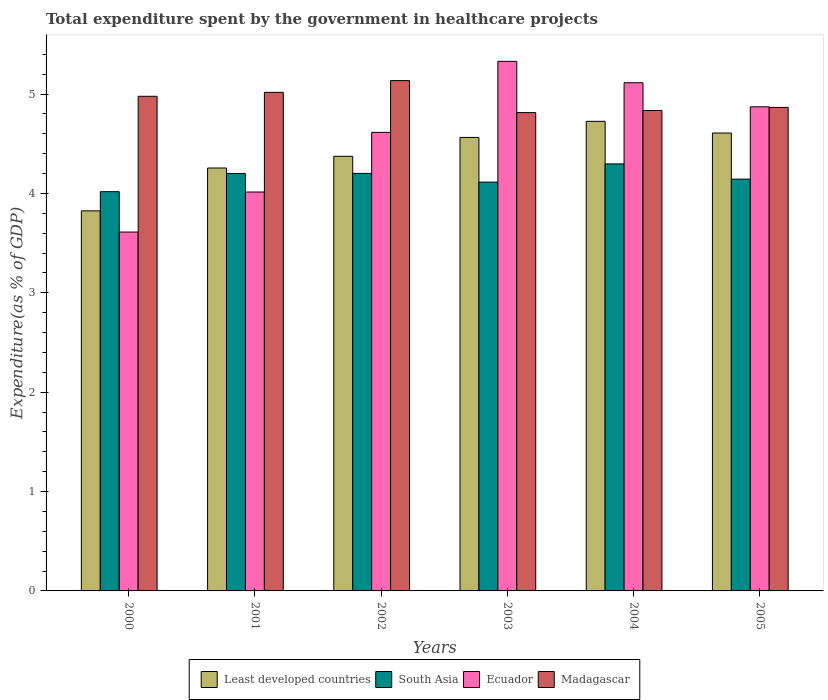How many groups of bars are there?
Make the answer very short. 6. Are the number of bars on each tick of the X-axis equal?
Keep it short and to the point. Yes. How many bars are there on the 2nd tick from the right?
Make the answer very short. 4. What is the total expenditure spent by the government in healthcare projects in South Asia in 2002?
Offer a very short reply. 4.2. Across all years, what is the maximum total expenditure spent by the government in healthcare projects in Madagascar?
Give a very brief answer. 5.14. Across all years, what is the minimum total expenditure spent by the government in healthcare projects in Ecuador?
Your answer should be compact. 3.61. In which year was the total expenditure spent by the government in healthcare projects in South Asia maximum?
Offer a terse response. 2004. What is the total total expenditure spent by the government in healthcare projects in Least developed countries in the graph?
Provide a succinct answer. 26.35. What is the difference between the total expenditure spent by the government in healthcare projects in Least developed countries in 2001 and that in 2003?
Your response must be concise. -0.31. What is the difference between the total expenditure spent by the government in healthcare projects in Least developed countries in 2000 and the total expenditure spent by the government in healthcare projects in Madagascar in 2001?
Your response must be concise. -1.19. What is the average total expenditure spent by the government in healthcare projects in Ecuador per year?
Give a very brief answer. 4.59. In the year 2003, what is the difference between the total expenditure spent by the government in healthcare projects in Madagascar and total expenditure spent by the government in healthcare projects in Least developed countries?
Ensure brevity in your answer.  0.25. What is the ratio of the total expenditure spent by the government in healthcare projects in Ecuador in 2003 to that in 2005?
Provide a succinct answer. 1.09. What is the difference between the highest and the second highest total expenditure spent by the government in healthcare projects in Madagascar?
Ensure brevity in your answer.  0.12. What is the difference between the highest and the lowest total expenditure spent by the government in healthcare projects in Madagascar?
Give a very brief answer. 0.32. Is it the case that in every year, the sum of the total expenditure spent by the government in healthcare projects in Least developed countries and total expenditure spent by the government in healthcare projects in South Asia is greater than the sum of total expenditure spent by the government in healthcare projects in Ecuador and total expenditure spent by the government in healthcare projects in Madagascar?
Provide a short and direct response. No. What does the 3rd bar from the left in 2001 represents?
Keep it short and to the point. Ecuador. What does the 1st bar from the right in 2005 represents?
Provide a succinct answer. Madagascar. Is it the case that in every year, the sum of the total expenditure spent by the government in healthcare projects in Ecuador and total expenditure spent by the government in healthcare projects in Least developed countries is greater than the total expenditure spent by the government in healthcare projects in South Asia?
Make the answer very short. Yes. How many bars are there?
Your answer should be compact. 24. Are all the bars in the graph horizontal?
Offer a terse response. No. How many years are there in the graph?
Offer a very short reply. 6. What is the difference between two consecutive major ticks on the Y-axis?
Provide a short and direct response. 1. Are the values on the major ticks of Y-axis written in scientific E-notation?
Ensure brevity in your answer.  No. Does the graph contain grids?
Your response must be concise. No. Where does the legend appear in the graph?
Offer a terse response. Bottom center. What is the title of the graph?
Keep it short and to the point. Total expenditure spent by the government in healthcare projects. What is the label or title of the Y-axis?
Your answer should be compact. Expenditure(as % of GDP). What is the Expenditure(as % of GDP) in Least developed countries in 2000?
Provide a succinct answer. 3.82. What is the Expenditure(as % of GDP) of South Asia in 2000?
Ensure brevity in your answer.  4.02. What is the Expenditure(as % of GDP) in Ecuador in 2000?
Offer a terse response. 3.61. What is the Expenditure(as % of GDP) in Madagascar in 2000?
Your answer should be compact. 4.98. What is the Expenditure(as % of GDP) of Least developed countries in 2001?
Offer a very short reply. 4.26. What is the Expenditure(as % of GDP) of South Asia in 2001?
Your response must be concise. 4.2. What is the Expenditure(as % of GDP) in Ecuador in 2001?
Your answer should be compact. 4.01. What is the Expenditure(as % of GDP) of Madagascar in 2001?
Make the answer very short. 5.02. What is the Expenditure(as % of GDP) of Least developed countries in 2002?
Offer a very short reply. 4.37. What is the Expenditure(as % of GDP) of South Asia in 2002?
Provide a succinct answer. 4.2. What is the Expenditure(as % of GDP) in Ecuador in 2002?
Offer a very short reply. 4.61. What is the Expenditure(as % of GDP) of Madagascar in 2002?
Your answer should be very brief. 5.14. What is the Expenditure(as % of GDP) in Least developed countries in 2003?
Provide a succinct answer. 4.56. What is the Expenditure(as % of GDP) of South Asia in 2003?
Keep it short and to the point. 4.11. What is the Expenditure(as % of GDP) in Ecuador in 2003?
Provide a succinct answer. 5.33. What is the Expenditure(as % of GDP) of Madagascar in 2003?
Make the answer very short. 4.81. What is the Expenditure(as % of GDP) of Least developed countries in 2004?
Offer a terse response. 4.72. What is the Expenditure(as % of GDP) in South Asia in 2004?
Your answer should be very brief. 4.3. What is the Expenditure(as % of GDP) in Ecuador in 2004?
Your answer should be very brief. 5.11. What is the Expenditure(as % of GDP) of Madagascar in 2004?
Your response must be concise. 4.83. What is the Expenditure(as % of GDP) of Least developed countries in 2005?
Your answer should be very brief. 4.61. What is the Expenditure(as % of GDP) of South Asia in 2005?
Give a very brief answer. 4.14. What is the Expenditure(as % of GDP) of Ecuador in 2005?
Offer a terse response. 4.87. What is the Expenditure(as % of GDP) of Madagascar in 2005?
Ensure brevity in your answer.  4.86. Across all years, what is the maximum Expenditure(as % of GDP) of Least developed countries?
Make the answer very short. 4.72. Across all years, what is the maximum Expenditure(as % of GDP) in South Asia?
Provide a succinct answer. 4.3. Across all years, what is the maximum Expenditure(as % of GDP) of Ecuador?
Provide a short and direct response. 5.33. Across all years, what is the maximum Expenditure(as % of GDP) of Madagascar?
Ensure brevity in your answer.  5.14. Across all years, what is the minimum Expenditure(as % of GDP) of Least developed countries?
Offer a terse response. 3.82. Across all years, what is the minimum Expenditure(as % of GDP) of South Asia?
Offer a terse response. 4.02. Across all years, what is the minimum Expenditure(as % of GDP) of Ecuador?
Offer a terse response. 3.61. Across all years, what is the minimum Expenditure(as % of GDP) of Madagascar?
Keep it short and to the point. 4.81. What is the total Expenditure(as % of GDP) in Least developed countries in the graph?
Offer a very short reply. 26.35. What is the total Expenditure(as % of GDP) of South Asia in the graph?
Offer a terse response. 24.97. What is the total Expenditure(as % of GDP) of Ecuador in the graph?
Ensure brevity in your answer.  27.55. What is the total Expenditure(as % of GDP) of Madagascar in the graph?
Provide a succinct answer. 29.64. What is the difference between the Expenditure(as % of GDP) in Least developed countries in 2000 and that in 2001?
Your answer should be compact. -0.43. What is the difference between the Expenditure(as % of GDP) of South Asia in 2000 and that in 2001?
Your response must be concise. -0.18. What is the difference between the Expenditure(as % of GDP) of Ecuador in 2000 and that in 2001?
Provide a short and direct response. -0.4. What is the difference between the Expenditure(as % of GDP) in Madagascar in 2000 and that in 2001?
Your answer should be compact. -0.04. What is the difference between the Expenditure(as % of GDP) in Least developed countries in 2000 and that in 2002?
Your response must be concise. -0.55. What is the difference between the Expenditure(as % of GDP) in South Asia in 2000 and that in 2002?
Your response must be concise. -0.18. What is the difference between the Expenditure(as % of GDP) of Ecuador in 2000 and that in 2002?
Provide a short and direct response. -1. What is the difference between the Expenditure(as % of GDP) of Madagascar in 2000 and that in 2002?
Make the answer very short. -0.16. What is the difference between the Expenditure(as % of GDP) of Least developed countries in 2000 and that in 2003?
Provide a succinct answer. -0.74. What is the difference between the Expenditure(as % of GDP) of South Asia in 2000 and that in 2003?
Provide a succinct answer. -0.1. What is the difference between the Expenditure(as % of GDP) in Ecuador in 2000 and that in 2003?
Offer a terse response. -1.72. What is the difference between the Expenditure(as % of GDP) of Madagascar in 2000 and that in 2003?
Provide a short and direct response. 0.16. What is the difference between the Expenditure(as % of GDP) of Least developed countries in 2000 and that in 2004?
Your answer should be compact. -0.9. What is the difference between the Expenditure(as % of GDP) in South Asia in 2000 and that in 2004?
Offer a very short reply. -0.28. What is the difference between the Expenditure(as % of GDP) of Ecuador in 2000 and that in 2004?
Provide a succinct answer. -1.5. What is the difference between the Expenditure(as % of GDP) in Madagascar in 2000 and that in 2004?
Offer a very short reply. 0.14. What is the difference between the Expenditure(as % of GDP) of Least developed countries in 2000 and that in 2005?
Your answer should be compact. -0.78. What is the difference between the Expenditure(as % of GDP) in South Asia in 2000 and that in 2005?
Give a very brief answer. -0.13. What is the difference between the Expenditure(as % of GDP) of Ecuador in 2000 and that in 2005?
Make the answer very short. -1.26. What is the difference between the Expenditure(as % of GDP) in Madagascar in 2000 and that in 2005?
Your answer should be compact. 0.11. What is the difference between the Expenditure(as % of GDP) of Least developed countries in 2001 and that in 2002?
Ensure brevity in your answer.  -0.12. What is the difference between the Expenditure(as % of GDP) of South Asia in 2001 and that in 2002?
Make the answer very short. -0. What is the difference between the Expenditure(as % of GDP) of Ecuador in 2001 and that in 2002?
Your answer should be compact. -0.6. What is the difference between the Expenditure(as % of GDP) of Madagascar in 2001 and that in 2002?
Offer a very short reply. -0.12. What is the difference between the Expenditure(as % of GDP) of Least developed countries in 2001 and that in 2003?
Make the answer very short. -0.31. What is the difference between the Expenditure(as % of GDP) of South Asia in 2001 and that in 2003?
Give a very brief answer. 0.09. What is the difference between the Expenditure(as % of GDP) of Ecuador in 2001 and that in 2003?
Offer a terse response. -1.31. What is the difference between the Expenditure(as % of GDP) of Madagascar in 2001 and that in 2003?
Offer a very short reply. 0.2. What is the difference between the Expenditure(as % of GDP) of Least developed countries in 2001 and that in 2004?
Your answer should be very brief. -0.47. What is the difference between the Expenditure(as % of GDP) of South Asia in 2001 and that in 2004?
Provide a short and direct response. -0.1. What is the difference between the Expenditure(as % of GDP) of Ecuador in 2001 and that in 2004?
Make the answer very short. -1.1. What is the difference between the Expenditure(as % of GDP) of Madagascar in 2001 and that in 2004?
Your answer should be compact. 0.18. What is the difference between the Expenditure(as % of GDP) in Least developed countries in 2001 and that in 2005?
Your response must be concise. -0.35. What is the difference between the Expenditure(as % of GDP) of South Asia in 2001 and that in 2005?
Your answer should be very brief. 0.06. What is the difference between the Expenditure(as % of GDP) in Ecuador in 2001 and that in 2005?
Your answer should be compact. -0.86. What is the difference between the Expenditure(as % of GDP) of Madagascar in 2001 and that in 2005?
Provide a succinct answer. 0.15. What is the difference between the Expenditure(as % of GDP) of Least developed countries in 2002 and that in 2003?
Ensure brevity in your answer.  -0.19. What is the difference between the Expenditure(as % of GDP) of South Asia in 2002 and that in 2003?
Offer a very short reply. 0.09. What is the difference between the Expenditure(as % of GDP) in Ecuador in 2002 and that in 2003?
Provide a succinct answer. -0.71. What is the difference between the Expenditure(as % of GDP) of Madagascar in 2002 and that in 2003?
Provide a succinct answer. 0.32. What is the difference between the Expenditure(as % of GDP) in Least developed countries in 2002 and that in 2004?
Provide a succinct answer. -0.35. What is the difference between the Expenditure(as % of GDP) of South Asia in 2002 and that in 2004?
Offer a very short reply. -0.1. What is the difference between the Expenditure(as % of GDP) in Ecuador in 2002 and that in 2004?
Provide a short and direct response. -0.5. What is the difference between the Expenditure(as % of GDP) in Madagascar in 2002 and that in 2004?
Ensure brevity in your answer.  0.3. What is the difference between the Expenditure(as % of GDP) of Least developed countries in 2002 and that in 2005?
Keep it short and to the point. -0.23. What is the difference between the Expenditure(as % of GDP) of South Asia in 2002 and that in 2005?
Offer a very short reply. 0.06. What is the difference between the Expenditure(as % of GDP) of Ecuador in 2002 and that in 2005?
Offer a very short reply. -0.26. What is the difference between the Expenditure(as % of GDP) of Madagascar in 2002 and that in 2005?
Offer a terse response. 0.27. What is the difference between the Expenditure(as % of GDP) of Least developed countries in 2003 and that in 2004?
Provide a short and direct response. -0.16. What is the difference between the Expenditure(as % of GDP) in South Asia in 2003 and that in 2004?
Ensure brevity in your answer.  -0.18. What is the difference between the Expenditure(as % of GDP) of Ecuador in 2003 and that in 2004?
Your answer should be compact. 0.22. What is the difference between the Expenditure(as % of GDP) of Madagascar in 2003 and that in 2004?
Your response must be concise. -0.02. What is the difference between the Expenditure(as % of GDP) of Least developed countries in 2003 and that in 2005?
Keep it short and to the point. -0.04. What is the difference between the Expenditure(as % of GDP) in South Asia in 2003 and that in 2005?
Give a very brief answer. -0.03. What is the difference between the Expenditure(as % of GDP) in Ecuador in 2003 and that in 2005?
Make the answer very short. 0.46. What is the difference between the Expenditure(as % of GDP) in Madagascar in 2003 and that in 2005?
Your answer should be very brief. -0.05. What is the difference between the Expenditure(as % of GDP) in Least developed countries in 2004 and that in 2005?
Your answer should be compact. 0.12. What is the difference between the Expenditure(as % of GDP) in South Asia in 2004 and that in 2005?
Make the answer very short. 0.15. What is the difference between the Expenditure(as % of GDP) in Ecuador in 2004 and that in 2005?
Offer a very short reply. 0.24. What is the difference between the Expenditure(as % of GDP) of Madagascar in 2004 and that in 2005?
Your response must be concise. -0.03. What is the difference between the Expenditure(as % of GDP) of Least developed countries in 2000 and the Expenditure(as % of GDP) of South Asia in 2001?
Your answer should be very brief. -0.38. What is the difference between the Expenditure(as % of GDP) in Least developed countries in 2000 and the Expenditure(as % of GDP) in Ecuador in 2001?
Your answer should be compact. -0.19. What is the difference between the Expenditure(as % of GDP) of Least developed countries in 2000 and the Expenditure(as % of GDP) of Madagascar in 2001?
Your response must be concise. -1.19. What is the difference between the Expenditure(as % of GDP) of South Asia in 2000 and the Expenditure(as % of GDP) of Ecuador in 2001?
Offer a terse response. 0. What is the difference between the Expenditure(as % of GDP) in South Asia in 2000 and the Expenditure(as % of GDP) in Madagascar in 2001?
Ensure brevity in your answer.  -1. What is the difference between the Expenditure(as % of GDP) in Ecuador in 2000 and the Expenditure(as % of GDP) in Madagascar in 2001?
Your answer should be compact. -1.41. What is the difference between the Expenditure(as % of GDP) of Least developed countries in 2000 and the Expenditure(as % of GDP) of South Asia in 2002?
Your answer should be very brief. -0.38. What is the difference between the Expenditure(as % of GDP) of Least developed countries in 2000 and the Expenditure(as % of GDP) of Ecuador in 2002?
Offer a terse response. -0.79. What is the difference between the Expenditure(as % of GDP) of Least developed countries in 2000 and the Expenditure(as % of GDP) of Madagascar in 2002?
Ensure brevity in your answer.  -1.31. What is the difference between the Expenditure(as % of GDP) of South Asia in 2000 and the Expenditure(as % of GDP) of Ecuador in 2002?
Your response must be concise. -0.6. What is the difference between the Expenditure(as % of GDP) of South Asia in 2000 and the Expenditure(as % of GDP) of Madagascar in 2002?
Your answer should be very brief. -1.12. What is the difference between the Expenditure(as % of GDP) in Ecuador in 2000 and the Expenditure(as % of GDP) in Madagascar in 2002?
Provide a short and direct response. -1.52. What is the difference between the Expenditure(as % of GDP) of Least developed countries in 2000 and the Expenditure(as % of GDP) of South Asia in 2003?
Make the answer very short. -0.29. What is the difference between the Expenditure(as % of GDP) in Least developed countries in 2000 and the Expenditure(as % of GDP) in Ecuador in 2003?
Your response must be concise. -1.5. What is the difference between the Expenditure(as % of GDP) in Least developed countries in 2000 and the Expenditure(as % of GDP) in Madagascar in 2003?
Offer a terse response. -0.99. What is the difference between the Expenditure(as % of GDP) in South Asia in 2000 and the Expenditure(as % of GDP) in Ecuador in 2003?
Ensure brevity in your answer.  -1.31. What is the difference between the Expenditure(as % of GDP) of South Asia in 2000 and the Expenditure(as % of GDP) of Madagascar in 2003?
Your answer should be very brief. -0.8. What is the difference between the Expenditure(as % of GDP) of Ecuador in 2000 and the Expenditure(as % of GDP) of Madagascar in 2003?
Give a very brief answer. -1.2. What is the difference between the Expenditure(as % of GDP) of Least developed countries in 2000 and the Expenditure(as % of GDP) of South Asia in 2004?
Provide a short and direct response. -0.47. What is the difference between the Expenditure(as % of GDP) of Least developed countries in 2000 and the Expenditure(as % of GDP) of Ecuador in 2004?
Your response must be concise. -1.29. What is the difference between the Expenditure(as % of GDP) of Least developed countries in 2000 and the Expenditure(as % of GDP) of Madagascar in 2004?
Your response must be concise. -1.01. What is the difference between the Expenditure(as % of GDP) of South Asia in 2000 and the Expenditure(as % of GDP) of Ecuador in 2004?
Offer a terse response. -1.1. What is the difference between the Expenditure(as % of GDP) in South Asia in 2000 and the Expenditure(as % of GDP) in Madagascar in 2004?
Offer a terse response. -0.82. What is the difference between the Expenditure(as % of GDP) of Ecuador in 2000 and the Expenditure(as % of GDP) of Madagascar in 2004?
Your response must be concise. -1.22. What is the difference between the Expenditure(as % of GDP) of Least developed countries in 2000 and the Expenditure(as % of GDP) of South Asia in 2005?
Provide a short and direct response. -0.32. What is the difference between the Expenditure(as % of GDP) in Least developed countries in 2000 and the Expenditure(as % of GDP) in Ecuador in 2005?
Ensure brevity in your answer.  -1.05. What is the difference between the Expenditure(as % of GDP) of Least developed countries in 2000 and the Expenditure(as % of GDP) of Madagascar in 2005?
Offer a terse response. -1.04. What is the difference between the Expenditure(as % of GDP) in South Asia in 2000 and the Expenditure(as % of GDP) in Ecuador in 2005?
Give a very brief answer. -0.85. What is the difference between the Expenditure(as % of GDP) of South Asia in 2000 and the Expenditure(as % of GDP) of Madagascar in 2005?
Give a very brief answer. -0.85. What is the difference between the Expenditure(as % of GDP) in Ecuador in 2000 and the Expenditure(as % of GDP) in Madagascar in 2005?
Ensure brevity in your answer.  -1.25. What is the difference between the Expenditure(as % of GDP) in Least developed countries in 2001 and the Expenditure(as % of GDP) in South Asia in 2002?
Your response must be concise. 0.05. What is the difference between the Expenditure(as % of GDP) in Least developed countries in 2001 and the Expenditure(as % of GDP) in Ecuador in 2002?
Provide a short and direct response. -0.36. What is the difference between the Expenditure(as % of GDP) in Least developed countries in 2001 and the Expenditure(as % of GDP) in Madagascar in 2002?
Your answer should be compact. -0.88. What is the difference between the Expenditure(as % of GDP) of South Asia in 2001 and the Expenditure(as % of GDP) of Ecuador in 2002?
Offer a very short reply. -0.41. What is the difference between the Expenditure(as % of GDP) of South Asia in 2001 and the Expenditure(as % of GDP) of Madagascar in 2002?
Give a very brief answer. -0.93. What is the difference between the Expenditure(as % of GDP) in Ecuador in 2001 and the Expenditure(as % of GDP) in Madagascar in 2002?
Your response must be concise. -1.12. What is the difference between the Expenditure(as % of GDP) of Least developed countries in 2001 and the Expenditure(as % of GDP) of South Asia in 2003?
Offer a terse response. 0.14. What is the difference between the Expenditure(as % of GDP) in Least developed countries in 2001 and the Expenditure(as % of GDP) in Ecuador in 2003?
Your response must be concise. -1.07. What is the difference between the Expenditure(as % of GDP) of Least developed countries in 2001 and the Expenditure(as % of GDP) of Madagascar in 2003?
Your response must be concise. -0.56. What is the difference between the Expenditure(as % of GDP) of South Asia in 2001 and the Expenditure(as % of GDP) of Ecuador in 2003?
Offer a very short reply. -1.13. What is the difference between the Expenditure(as % of GDP) in South Asia in 2001 and the Expenditure(as % of GDP) in Madagascar in 2003?
Ensure brevity in your answer.  -0.61. What is the difference between the Expenditure(as % of GDP) of Ecuador in 2001 and the Expenditure(as % of GDP) of Madagascar in 2003?
Your answer should be compact. -0.8. What is the difference between the Expenditure(as % of GDP) in Least developed countries in 2001 and the Expenditure(as % of GDP) in South Asia in 2004?
Keep it short and to the point. -0.04. What is the difference between the Expenditure(as % of GDP) in Least developed countries in 2001 and the Expenditure(as % of GDP) in Ecuador in 2004?
Ensure brevity in your answer.  -0.86. What is the difference between the Expenditure(as % of GDP) in Least developed countries in 2001 and the Expenditure(as % of GDP) in Madagascar in 2004?
Your response must be concise. -0.58. What is the difference between the Expenditure(as % of GDP) in South Asia in 2001 and the Expenditure(as % of GDP) in Ecuador in 2004?
Offer a terse response. -0.91. What is the difference between the Expenditure(as % of GDP) in South Asia in 2001 and the Expenditure(as % of GDP) in Madagascar in 2004?
Provide a succinct answer. -0.63. What is the difference between the Expenditure(as % of GDP) of Ecuador in 2001 and the Expenditure(as % of GDP) of Madagascar in 2004?
Your response must be concise. -0.82. What is the difference between the Expenditure(as % of GDP) in Least developed countries in 2001 and the Expenditure(as % of GDP) in South Asia in 2005?
Your answer should be compact. 0.11. What is the difference between the Expenditure(as % of GDP) of Least developed countries in 2001 and the Expenditure(as % of GDP) of Ecuador in 2005?
Your answer should be compact. -0.62. What is the difference between the Expenditure(as % of GDP) of Least developed countries in 2001 and the Expenditure(as % of GDP) of Madagascar in 2005?
Your response must be concise. -0.61. What is the difference between the Expenditure(as % of GDP) in South Asia in 2001 and the Expenditure(as % of GDP) in Ecuador in 2005?
Make the answer very short. -0.67. What is the difference between the Expenditure(as % of GDP) of South Asia in 2001 and the Expenditure(as % of GDP) of Madagascar in 2005?
Provide a succinct answer. -0.66. What is the difference between the Expenditure(as % of GDP) of Ecuador in 2001 and the Expenditure(as % of GDP) of Madagascar in 2005?
Keep it short and to the point. -0.85. What is the difference between the Expenditure(as % of GDP) of Least developed countries in 2002 and the Expenditure(as % of GDP) of South Asia in 2003?
Offer a very short reply. 0.26. What is the difference between the Expenditure(as % of GDP) in Least developed countries in 2002 and the Expenditure(as % of GDP) in Ecuador in 2003?
Provide a short and direct response. -0.96. What is the difference between the Expenditure(as % of GDP) in Least developed countries in 2002 and the Expenditure(as % of GDP) in Madagascar in 2003?
Keep it short and to the point. -0.44. What is the difference between the Expenditure(as % of GDP) in South Asia in 2002 and the Expenditure(as % of GDP) in Ecuador in 2003?
Offer a very short reply. -1.13. What is the difference between the Expenditure(as % of GDP) of South Asia in 2002 and the Expenditure(as % of GDP) of Madagascar in 2003?
Provide a succinct answer. -0.61. What is the difference between the Expenditure(as % of GDP) of Ecuador in 2002 and the Expenditure(as % of GDP) of Madagascar in 2003?
Offer a very short reply. -0.2. What is the difference between the Expenditure(as % of GDP) in Least developed countries in 2002 and the Expenditure(as % of GDP) in South Asia in 2004?
Ensure brevity in your answer.  0.08. What is the difference between the Expenditure(as % of GDP) of Least developed countries in 2002 and the Expenditure(as % of GDP) of Ecuador in 2004?
Your answer should be very brief. -0.74. What is the difference between the Expenditure(as % of GDP) in Least developed countries in 2002 and the Expenditure(as % of GDP) in Madagascar in 2004?
Your answer should be compact. -0.46. What is the difference between the Expenditure(as % of GDP) of South Asia in 2002 and the Expenditure(as % of GDP) of Ecuador in 2004?
Offer a very short reply. -0.91. What is the difference between the Expenditure(as % of GDP) in South Asia in 2002 and the Expenditure(as % of GDP) in Madagascar in 2004?
Give a very brief answer. -0.63. What is the difference between the Expenditure(as % of GDP) of Ecuador in 2002 and the Expenditure(as % of GDP) of Madagascar in 2004?
Ensure brevity in your answer.  -0.22. What is the difference between the Expenditure(as % of GDP) in Least developed countries in 2002 and the Expenditure(as % of GDP) in South Asia in 2005?
Your answer should be compact. 0.23. What is the difference between the Expenditure(as % of GDP) of Least developed countries in 2002 and the Expenditure(as % of GDP) of Ecuador in 2005?
Give a very brief answer. -0.5. What is the difference between the Expenditure(as % of GDP) in Least developed countries in 2002 and the Expenditure(as % of GDP) in Madagascar in 2005?
Offer a very short reply. -0.49. What is the difference between the Expenditure(as % of GDP) of South Asia in 2002 and the Expenditure(as % of GDP) of Ecuador in 2005?
Offer a terse response. -0.67. What is the difference between the Expenditure(as % of GDP) of South Asia in 2002 and the Expenditure(as % of GDP) of Madagascar in 2005?
Your response must be concise. -0.66. What is the difference between the Expenditure(as % of GDP) in Ecuador in 2002 and the Expenditure(as % of GDP) in Madagascar in 2005?
Ensure brevity in your answer.  -0.25. What is the difference between the Expenditure(as % of GDP) in Least developed countries in 2003 and the Expenditure(as % of GDP) in South Asia in 2004?
Offer a very short reply. 0.27. What is the difference between the Expenditure(as % of GDP) of Least developed countries in 2003 and the Expenditure(as % of GDP) of Ecuador in 2004?
Your answer should be compact. -0.55. What is the difference between the Expenditure(as % of GDP) of Least developed countries in 2003 and the Expenditure(as % of GDP) of Madagascar in 2004?
Make the answer very short. -0.27. What is the difference between the Expenditure(as % of GDP) in South Asia in 2003 and the Expenditure(as % of GDP) in Ecuador in 2004?
Make the answer very short. -1. What is the difference between the Expenditure(as % of GDP) in South Asia in 2003 and the Expenditure(as % of GDP) in Madagascar in 2004?
Your answer should be compact. -0.72. What is the difference between the Expenditure(as % of GDP) of Ecuador in 2003 and the Expenditure(as % of GDP) of Madagascar in 2004?
Keep it short and to the point. 0.49. What is the difference between the Expenditure(as % of GDP) in Least developed countries in 2003 and the Expenditure(as % of GDP) in South Asia in 2005?
Your response must be concise. 0.42. What is the difference between the Expenditure(as % of GDP) of Least developed countries in 2003 and the Expenditure(as % of GDP) of Ecuador in 2005?
Offer a terse response. -0.31. What is the difference between the Expenditure(as % of GDP) in Least developed countries in 2003 and the Expenditure(as % of GDP) in Madagascar in 2005?
Keep it short and to the point. -0.3. What is the difference between the Expenditure(as % of GDP) of South Asia in 2003 and the Expenditure(as % of GDP) of Ecuador in 2005?
Offer a very short reply. -0.76. What is the difference between the Expenditure(as % of GDP) of South Asia in 2003 and the Expenditure(as % of GDP) of Madagascar in 2005?
Ensure brevity in your answer.  -0.75. What is the difference between the Expenditure(as % of GDP) in Ecuador in 2003 and the Expenditure(as % of GDP) in Madagascar in 2005?
Give a very brief answer. 0.46. What is the difference between the Expenditure(as % of GDP) in Least developed countries in 2004 and the Expenditure(as % of GDP) in South Asia in 2005?
Provide a short and direct response. 0.58. What is the difference between the Expenditure(as % of GDP) in Least developed countries in 2004 and the Expenditure(as % of GDP) in Ecuador in 2005?
Provide a short and direct response. -0.15. What is the difference between the Expenditure(as % of GDP) of Least developed countries in 2004 and the Expenditure(as % of GDP) of Madagascar in 2005?
Offer a terse response. -0.14. What is the difference between the Expenditure(as % of GDP) in South Asia in 2004 and the Expenditure(as % of GDP) in Ecuador in 2005?
Your response must be concise. -0.57. What is the difference between the Expenditure(as % of GDP) in South Asia in 2004 and the Expenditure(as % of GDP) in Madagascar in 2005?
Make the answer very short. -0.57. What is the difference between the Expenditure(as % of GDP) in Ecuador in 2004 and the Expenditure(as % of GDP) in Madagascar in 2005?
Keep it short and to the point. 0.25. What is the average Expenditure(as % of GDP) of Least developed countries per year?
Your response must be concise. 4.39. What is the average Expenditure(as % of GDP) in South Asia per year?
Your response must be concise. 4.16. What is the average Expenditure(as % of GDP) of Ecuador per year?
Your response must be concise. 4.59. What is the average Expenditure(as % of GDP) in Madagascar per year?
Offer a very short reply. 4.94. In the year 2000, what is the difference between the Expenditure(as % of GDP) of Least developed countries and Expenditure(as % of GDP) of South Asia?
Provide a short and direct response. -0.19. In the year 2000, what is the difference between the Expenditure(as % of GDP) in Least developed countries and Expenditure(as % of GDP) in Ecuador?
Offer a terse response. 0.21. In the year 2000, what is the difference between the Expenditure(as % of GDP) in Least developed countries and Expenditure(as % of GDP) in Madagascar?
Give a very brief answer. -1.15. In the year 2000, what is the difference between the Expenditure(as % of GDP) in South Asia and Expenditure(as % of GDP) in Ecuador?
Make the answer very short. 0.41. In the year 2000, what is the difference between the Expenditure(as % of GDP) in South Asia and Expenditure(as % of GDP) in Madagascar?
Your answer should be very brief. -0.96. In the year 2000, what is the difference between the Expenditure(as % of GDP) of Ecuador and Expenditure(as % of GDP) of Madagascar?
Keep it short and to the point. -1.37. In the year 2001, what is the difference between the Expenditure(as % of GDP) of Least developed countries and Expenditure(as % of GDP) of South Asia?
Provide a short and direct response. 0.05. In the year 2001, what is the difference between the Expenditure(as % of GDP) in Least developed countries and Expenditure(as % of GDP) in Ecuador?
Your answer should be compact. 0.24. In the year 2001, what is the difference between the Expenditure(as % of GDP) in Least developed countries and Expenditure(as % of GDP) in Madagascar?
Provide a succinct answer. -0.76. In the year 2001, what is the difference between the Expenditure(as % of GDP) in South Asia and Expenditure(as % of GDP) in Ecuador?
Provide a succinct answer. 0.19. In the year 2001, what is the difference between the Expenditure(as % of GDP) of South Asia and Expenditure(as % of GDP) of Madagascar?
Make the answer very short. -0.82. In the year 2001, what is the difference between the Expenditure(as % of GDP) of Ecuador and Expenditure(as % of GDP) of Madagascar?
Keep it short and to the point. -1. In the year 2002, what is the difference between the Expenditure(as % of GDP) in Least developed countries and Expenditure(as % of GDP) in South Asia?
Provide a succinct answer. 0.17. In the year 2002, what is the difference between the Expenditure(as % of GDP) in Least developed countries and Expenditure(as % of GDP) in Ecuador?
Make the answer very short. -0.24. In the year 2002, what is the difference between the Expenditure(as % of GDP) of Least developed countries and Expenditure(as % of GDP) of Madagascar?
Provide a succinct answer. -0.76. In the year 2002, what is the difference between the Expenditure(as % of GDP) in South Asia and Expenditure(as % of GDP) in Ecuador?
Make the answer very short. -0.41. In the year 2002, what is the difference between the Expenditure(as % of GDP) in South Asia and Expenditure(as % of GDP) in Madagascar?
Offer a very short reply. -0.93. In the year 2002, what is the difference between the Expenditure(as % of GDP) of Ecuador and Expenditure(as % of GDP) of Madagascar?
Make the answer very short. -0.52. In the year 2003, what is the difference between the Expenditure(as % of GDP) in Least developed countries and Expenditure(as % of GDP) in South Asia?
Ensure brevity in your answer.  0.45. In the year 2003, what is the difference between the Expenditure(as % of GDP) in Least developed countries and Expenditure(as % of GDP) in Ecuador?
Your answer should be compact. -0.77. In the year 2003, what is the difference between the Expenditure(as % of GDP) in Least developed countries and Expenditure(as % of GDP) in Madagascar?
Keep it short and to the point. -0.25. In the year 2003, what is the difference between the Expenditure(as % of GDP) in South Asia and Expenditure(as % of GDP) in Ecuador?
Your response must be concise. -1.22. In the year 2003, what is the difference between the Expenditure(as % of GDP) of South Asia and Expenditure(as % of GDP) of Madagascar?
Provide a short and direct response. -0.7. In the year 2003, what is the difference between the Expenditure(as % of GDP) of Ecuador and Expenditure(as % of GDP) of Madagascar?
Keep it short and to the point. 0.52. In the year 2004, what is the difference between the Expenditure(as % of GDP) of Least developed countries and Expenditure(as % of GDP) of South Asia?
Give a very brief answer. 0.43. In the year 2004, what is the difference between the Expenditure(as % of GDP) of Least developed countries and Expenditure(as % of GDP) of Ecuador?
Provide a succinct answer. -0.39. In the year 2004, what is the difference between the Expenditure(as % of GDP) of Least developed countries and Expenditure(as % of GDP) of Madagascar?
Your answer should be very brief. -0.11. In the year 2004, what is the difference between the Expenditure(as % of GDP) of South Asia and Expenditure(as % of GDP) of Ecuador?
Give a very brief answer. -0.82. In the year 2004, what is the difference between the Expenditure(as % of GDP) of South Asia and Expenditure(as % of GDP) of Madagascar?
Ensure brevity in your answer.  -0.54. In the year 2004, what is the difference between the Expenditure(as % of GDP) of Ecuador and Expenditure(as % of GDP) of Madagascar?
Your answer should be very brief. 0.28. In the year 2005, what is the difference between the Expenditure(as % of GDP) in Least developed countries and Expenditure(as % of GDP) in South Asia?
Make the answer very short. 0.46. In the year 2005, what is the difference between the Expenditure(as % of GDP) in Least developed countries and Expenditure(as % of GDP) in Ecuador?
Make the answer very short. -0.26. In the year 2005, what is the difference between the Expenditure(as % of GDP) of Least developed countries and Expenditure(as % of GDP) of Madagascar?
Give a very brief answer. -0.26. In the year 2005, what is the difference between the Expenditure(as % of GDP) in South Asia and Expenditure(as % of GDP) in Ecuador?
Ensure brevity in your answer.  -0.73. In the year 2005, what is the difference between the Expenditure(as % of GDP) in South Asia and Expenditure(as % of GDP) in Madagascar?
Keep it short and to the point. -0.72. In the year 2005, what is the difference between the Expenditure(as % of GDP) in Ecuador and Expenditure(as % of GDP) in Madagascar?
Provide a short and direct response. 0.01. What is the ratio of the Expenditure(as % of GDP) in Least developed countries in 2000 to that in 2001?
Ensure brevity in your answer.  0.9. What is the ratio of the Expenditure(as % of GDP) of South Asia in 2000 to that in 2001?
Your answer should be very brief. 0.96. What is the ratio of the Expenditure(as % of GDP) in Ecuador in 2000 to that in 2001?
Keep it short and to the point. 0.9. What is the ratio of the Expenditure(as % of GDP) of Madagascar in 2000 to that in 2001?
Provide a short and direct response. 0.99. What is the ratio of the Expenditure(as % of GDP) in Least developed countries in 2000 to that in 2002?
Your response must be concise. 0.87. What is the ratio of the Expenditure(as % of GDP) of South Asia in 2000 to that in 2002?
Your response must be concise. 0.96. What is the ratio of the Expenditure(as % of GDP) of Ecuador in 2000 to that in 2002?
Give a very brief answer. 0.78. What is the ratio of the Expenditure(as % of GDP) in Madagascar in 2000 to that in 2002?
Offer a terse response. 0.97. What is the ratio of the Expenditure(as % of GDP) of Least developed countries in 2000 to that in 2003?
Give a very brief answer. 0.84. What is the ratio of the Expenditure(as % of GDP) in South Asia in 2000 to that in 2003?
Give a very brief answer. 0.98. What is the ratio of the Expenditure(as % of GDP) of Ecuador in 2000 to that in 2003?
Give a very brief answer. 0.68. What is the ratio of the Expenditure(as % of GDP) in Madagascar in 2000 to that in 2003?
Your answer should be compact. 1.03. What is the ratio of the Expenditure(as % of GDP) of Least developed countries in 2000 to that in 2004?
Ensure brevity in your answer.  0.81. What is the ratio of the Expenditure(as % of GDP) in South Asia in 2000 to that in 2004?
Provide a short and direct response. 0.93. What is the ratio of the Expenditure(as % of GDP) in Ecuador in 2000 to that in 2004?
Provide a succinct answer. 0.71. What is the ratio of the Expenditure(as % of GDP) in Madagascar in 2000 to that in 2004?
Your answer should be very brief. 1.03. What is the ratio of the Expenditure(as % of GDP) in Least developed countries in 2000 to that in 2005?
Offer a terse response. 0.83. What is the ratio of the Expenditure(as % of GDP) in South Asia in 2000 to that in 2005?
Ensure brevity in your answer.  0.97. What is the ratio of the Expenditure(as % of GDP) of Ecuador in 2000 to that in 2005?
Offer a very short reply. 0.74. What is the ratio of the Expenditure(as % of GDP) of Madagascar in 2000 to that in 2005?
Ensure brevity in your answer.  1.02. What is the ratio of the Expenditure(as % of GDP) of Least developed countries in 2001 to that in 2002?
Your answer should be very brief. 0.97. What is the ratio of the Expenditure(as % of GDP) of South Asia in 2001 to that in 2002?
Ensure brevity in your answer.  1. What is the ratio of the Expenditure(as % of GDP) in Ecuador in 2001 to that in 2002?
Provide a short and direct response. 0.87. What is the ratio of the Expenditure(as % of GDP) in Madagascar in 2001 to that in 2002?
Make the answer very short. 0.98. What is the ratio of the Expenditure(as % of GDP) in Least developed countries in 2001 to that in 2003?
Keep it short and to the point. 0.93. What is the ratio of the Expenditure(as % of GDP) in South Asia in 2001 to that in 2003?
Give a very brief answer. 1.02. What is the ratio of the Expenditure(as % of GDP) of Ecuador in 2001 to that in 2003?
Provide a succinct answer. 0.75. What is the ratio of the Expenditure(as % of GDP) of Madagascar in 2001 to that in 2003?
Your response must be concise. 1.04. What is the ratio of the Expenditure(as % of GDP) in Least developed countries in 2001 to that in 2004?
Ensure brevity in your answer.  0.9. What is the ratio of the Expenditure(as % of GDP) in South Asia in 2001 to that in 2004?
Offer a very short reply. 0.98. What is the ratio of the Expenditure(as % of GDP) of Ecuador in 2001 to that in 2004?
Your response must be concise. 0.79. What is the ratio of the Expenditure(as % of GDP) of Madagascar in 2001 to that in 2004?
Provide a short and direct response. 1.04. What is the ratio of the Expenditure(as % of GDP) in Least developed countries in 2001 to that in 2005?
Keep it short and to the point. 0.92. What is the ratio of the Expenditure(as % of GDP) in South Asia in 2001 to that in 2005?
Your response must be concise. 1.01. What is the ratio of the Expenditure(as % of GDP) in Ecuador in 2001 to that in 2005?
Keep it short and to the point. 0.82. What is the ratio of the Expenditure(as % of GDP) in Madagascar in 2001 to that in 2005?
Offer a terse response. 1.03. What is the ratio of the Expenditure(as % of GDP) of Least developed countries in 2002 to that in 2003?
Your answer should be very brief. 0.96. What is the ratio of the Expenditure(as % of GDP) in South Asia in 2002 to that in 2003?
Provide a succinct answer. 1.02. What is the ratio of the Expenditure(as % of GDP) of Ecuador in 2002 to that in 2003?
Your response must be concise. 0.87. What is the ratio of the Expenditure(as % of GDP) in Madagascar in 2002 to that in 2003?
Ensure brevity in your answer.  1.07. What is the ratio of the Expenditure(as % of GDP) of Least developed countries in 2002 to that in 2004?
Make the answer very short. 0.93. What is the ratio of the Expenditure(as % of GDP) in South Asia in 2002 to that in 2004?
Keep it short and to the point. 0.98. What is the ratio of the Expenditure(as % of GDP) in Ecuador in 2002 to that in 2004?
Give a very brief answer. 0.9. What is the ratio of the Expenditure(as % of GDP) of Madagascar in 2002 to that in 2004?
Make the answer very short. 1.06. What is the ratio of the Expenditure(as % of GDP) of Least developed countries in 2002 to that in 2005?
Your answer should be compact. 0.95. What is the ratio of the Expenditure(as % of GDP) in South Asia in 2002 to that in 2005?
Make the answer very short. 1.01. What is the ratio of the Expenditure(as % of GDP) of Ecuador in 2002 to that in 2005?
Give a very brief answer. 0.95. What is the ratio of the Expenditure(as % of GDP) of Madagascar in 2002 to that in 2005?
Ensure brevity in your answer.  1.06. What is the ratio of the Expenditure(as % of GDP) in Least developed countries in 2003 to that in 2004?
Offer a terse response. 0.97. What is the ratio of the Expenditure(as % of GDP) of South Asia in 2003 to that in 2004?
Make the answer very short. 0.96. What is the ratio of the Expenditure(as % of GDP) of Ecuador in 2003 to that in 2004?
Your answer should be very brief. 1.04. What is the ratio of the Expenditure(as % of GDP) in Madagascar in 2003 to that in 2004?
Provide a short and direct response. 1. What is the ratio of the Expenditure(as % of GDP) of Least developed countries in 2003 to that in 2005?
Provide a succinct answer. 0.99. What is the ratio of the Expenditure(as % of GDP) of Ecuador in 2003 to that in 2005?
Provide a short and direct response. 1.09. What is the ratio of the Expenditure(as % of GDP) in Madagascar in 2003 to that in 2005?
Offer a very short reply. 0.99. What is the ratio of the Expenditure(as % of GDP) in Least developed countries in 2004 to that in 2005?
Make the answer very short. 1.03. What is the ratio of the Expenditure(as % of GDP) of South Asia in 2004 to that in 2005?
Give a very brief answer. 1.04. What is the ratio of the Expenditure(as % of GDP) of Ecuador in 2004 to that in 2005?
Your answer should be compact. 1.05. What is the ratio of the Expenditure(as % of GDP) of Madagascar in 2004 to that in 2005?
Make the answer very short. 0.99. What is the difference between the highest and the second highest Expenditure(as % of GDP) in Least developed countries?
Give a very brief answer. 0.12. What is the difference between the highest and the second highest Expenditure(as % of GDP) of South Asia?
Give a very brief answer. 0.1. What is the difference between the highest and the second highest Expenditure(as % of GDP) in Ecuador?
Make the answer very short. 0.22. What is the difference between the highest and the second highest Expenditure(as % of GDP) in Madagascar?
Offer a terse response. 0.12. What is the difference between the highest and the lowest Expenditure(as % of GDP) in Least developed countries?
Provide a short and direct response. 0.9. What is the difference between the highest and the lowest Expenditure(as % of GDP) of South Asia?
Make the answer very short. 0.28. What is the difference between the highest and the lowest Expenditure(as % of GDP) in Ecuador?
Offer a terse response. 1.72. What is the difference between the highest and the lowest Expenditure(as % of GDP) of Madagascar?
Keep it short and to the point. 0.32. 